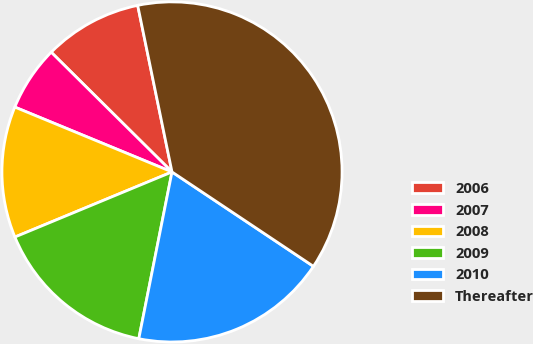Convert chart to OTSL. <chart><loc_0><loc_0><loc_500><loc_500><pie_chart><fcel>2006<fcel>2007<fcel>2008<fcel>2009<fcel>2010<fcel>Thereafter<nl><fcel>9.34%<fcel>6.2%<fcel>12.48%<fcel>15.62%<fcel>18.76%<fcel>37.6%<nl></chart> 